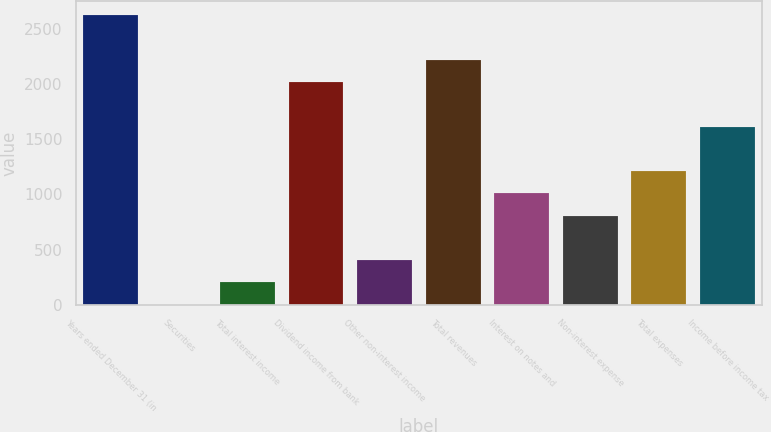Convert chart. <chart><loc_0><loc_0><loc_500><loc_500><bar_chart><fcel>Years ended December 31 (in<fcel>Securities<fcel>Total interest income<fcel>Dividend income from bank<fcel>Other non-interest income<fcel>Total revenues<fcel>Interest on notes and<fcel>Non-interest expense<fcel>Total expenses<fcel>Income before income tax<nl><fcel>2623.28<fcel>0.4<fcel>202.16<fcel>2018<fcel>403.92<fcel>2219.76<fcel>1009.2<fcel>807.44<fcel>1210.96<fcel>1614.48<nl></chart> 